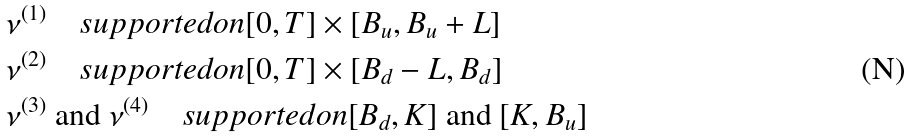<formula> <loc_0><loc_0><loc_500><loc_500>& \nu ^ { ( 1 ) } \quad s u p p o r t e d o n [ 0 , T ] \times [ B _ { u } , B _ { u } + L ] \\ & \nu ^ { ( 2 ) } \quad s u p p o r t e d o n [ 0 , T ] \times [ B _ { d } - L , B _ { d } ] \\ & \nu ^ { ( 3 ) } \ \text {and} \ \nu ^ { ( 4 ) } \quad s u p p o r t e d o n [ B _ { d } , K ] \ \text {and} \ [ K , B _ { u } ]</formula> 